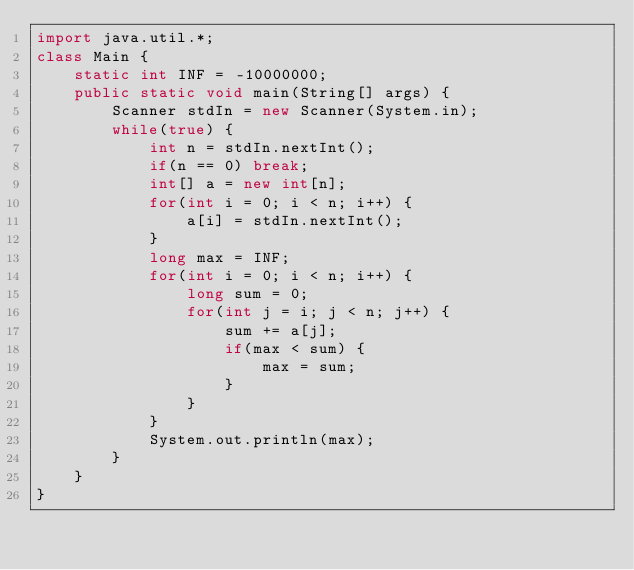<code> <loc_0><loc_0><loc_500><loc_500><_Java_>import java.util.*;
class Main {
	static int INF = -10000000;
	public static void main(String[] args) {
		Scanner stdIn = new Scanner(System.in);
		while(true) {
			int n = stdIn.nextInt();
			if(n == 0) break;
			int[] a = new int[n];
			for(int i = 0; i < n; i++) {
				a[i] = stdIn.nextInt();
			}
			long max = INF;
			for(int i = 0; i < n; i++) {
				long sum = 0;
				for(int j = i; j < n; j++) {
					sum += a[j];
					if(max < sum) {
						max = sum;
					}
				}
			}
			System.out.println(max);
		}
	}
}</code> 